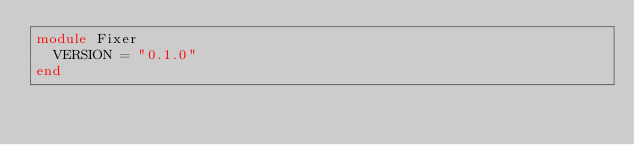<code> <loc_0><loc_0><loc_500><loc_500><_Ruby_>module Fixer
  VERSION = "0.1.0"
end
</code> 